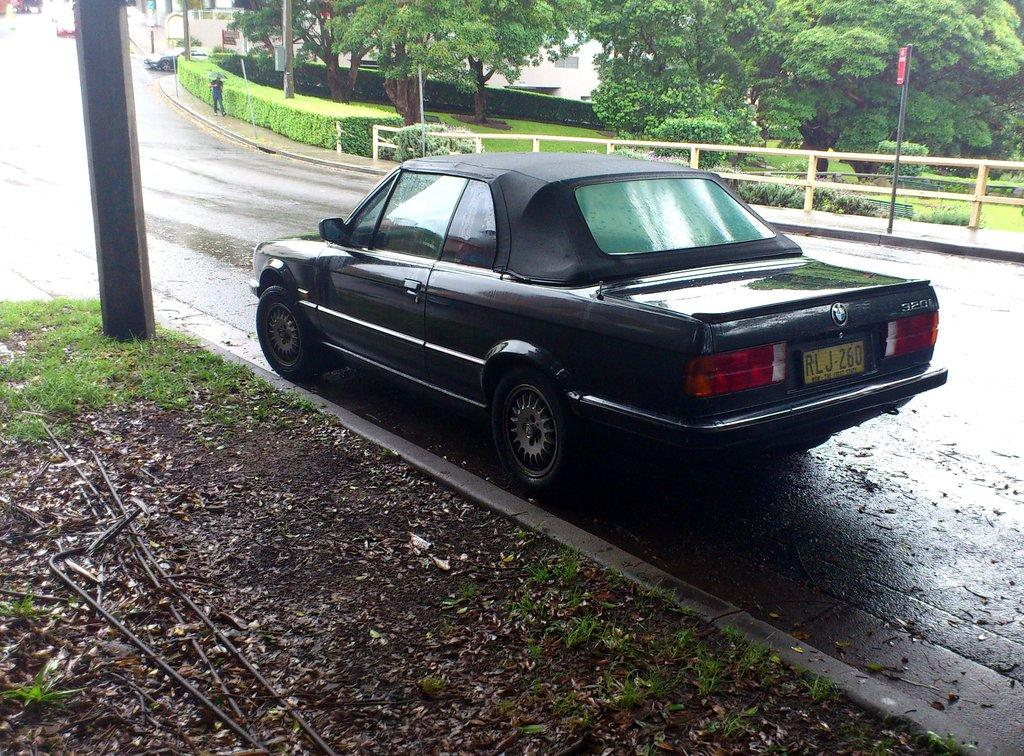What can be seen on the road in the image? There are vehicles on the road in the image. Are there any people on the road in the image? Yes, there is a person is on the road in the image. What can be seen in the background of the image? There are trees, plants, buildings, and poles in the background of the image. Can you see any waves in the image? There are no waves present in the image, as it features a road, vehicles, a person, and various background elements. Is there a rod visible in the image? There is no rod present in the image. 